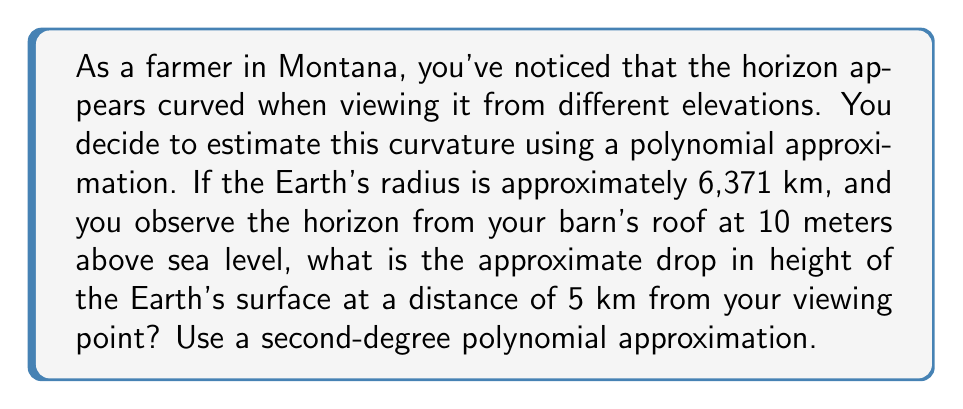Provide a solution to this math problem. Let's approach this step-by-step:

1) The Earth's curvature can be approximated by a parabola, which is a second-degree polynomial. The general form is:

   $$y = ax^2$$

   Where $y$ is the drop in height, $x$ is the distance from the viewing point, and $a$ is a constant we need to determine.

2) To find $a$, we can use the Earth's radius $R$. At a distance $x$ from the viewing point, the drop $y$ is related to $R$ by the Pythagorean theorem:

   $$(R+y)^2 + x^2 = R^2$$

3) Expanding this:

   $$R^2 + 2Ry + y^2 + x^2 = R^2$$

4) Simplify and ignore $y^2$ as it's very small compared to the other terms:

   $$2Ry \approx x^2$$

5) Solving for $y$:

   $$y \approx \frac{x^2}{2R}$$

6) Comparing this to our parabola equation, we see that:

   $$a = \frac{1}{2R}$$

7) Plugging in $R = 6,371,000$ meters:

   $$a = \frac{1}{2(6,371,000)} \approx 7.85 \times 10^{-8}$$

8) Now our equation is:

   $$y \approx 7.85 \times 10^{-8} x^2$$

9) For $x = 5000$ meters:

   $$y \approx 7.85 \times 10^{-8} \times 5000^2 \approx 1.96 \text{ meters}$$

10) However, we're viewing from 10 meters above sea level, so we need to subtract this:

    $$1.96 - 10 = -8.04 \text{ meters}$$

The negative value indicates that the surface is below our viewing point.
Answer: -8.04 meters 